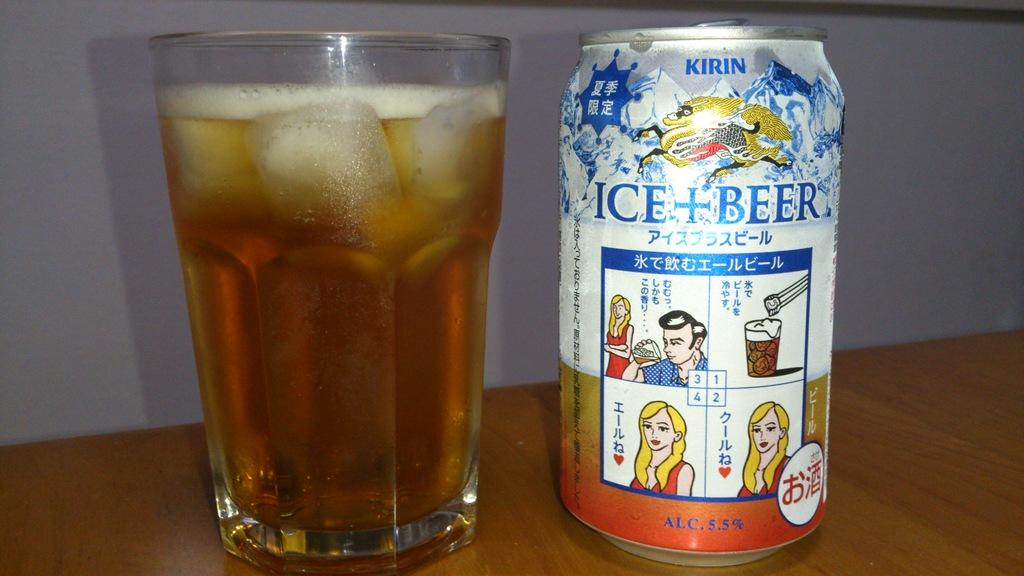<image>
Provide a brief description of the given image. A fill glass with liquid and foam on top beside a Ice Beer can beside it. 